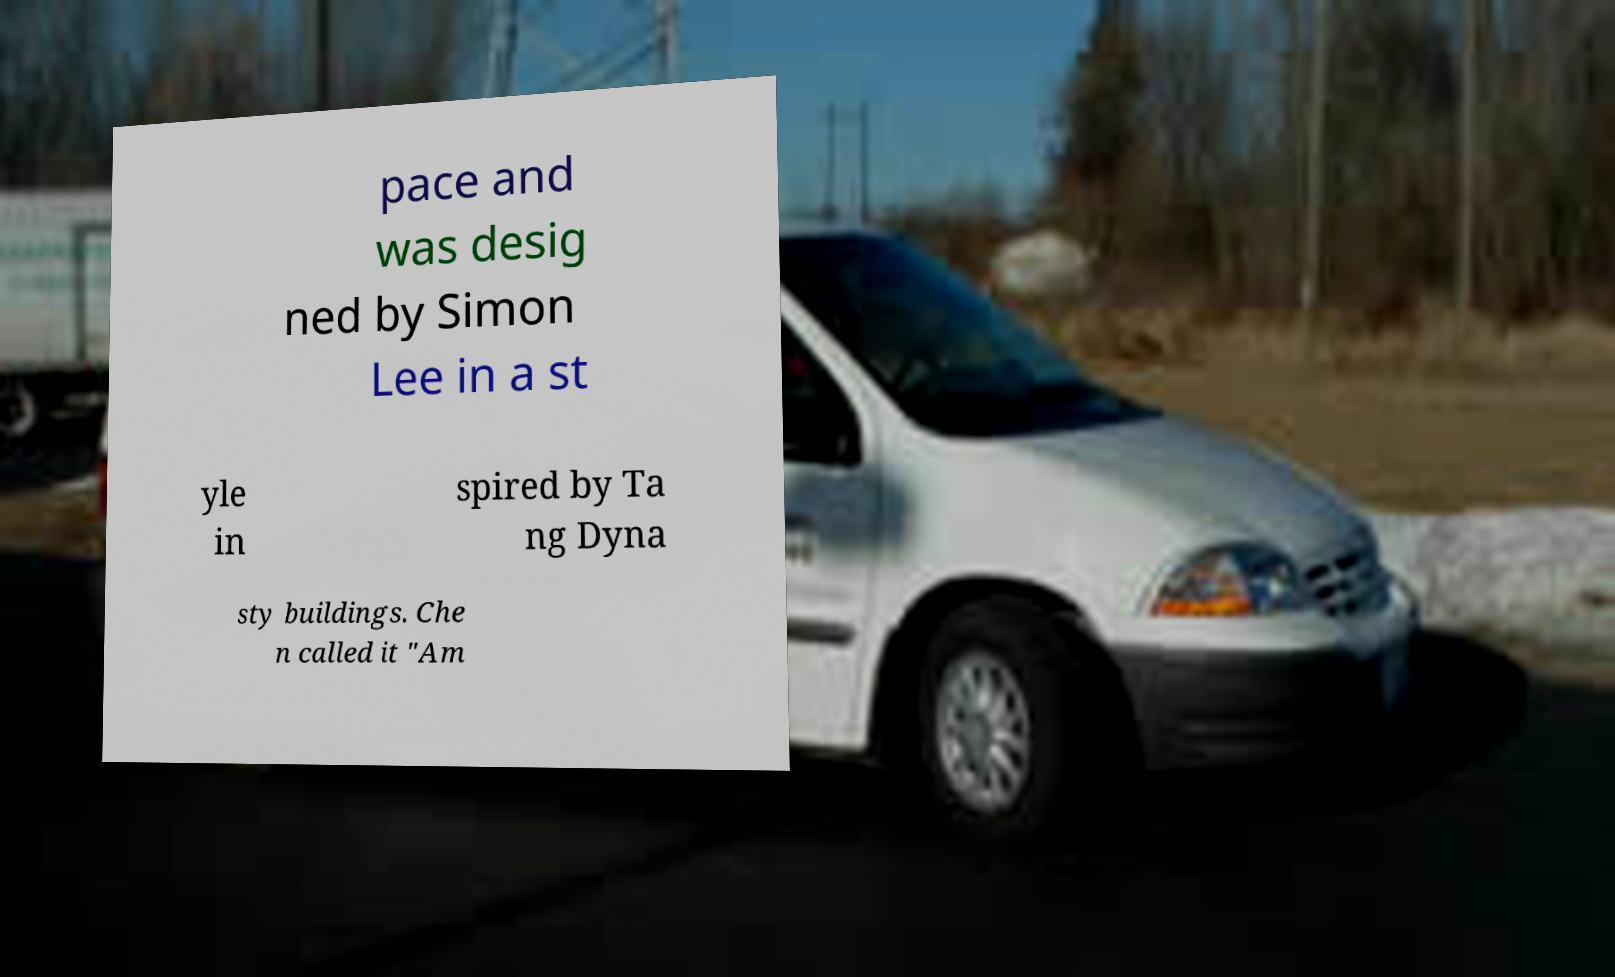Could you assist in decoding the text presented in this image and type it out clearly? pace and was desig ned by Simon Lee in a st yle in spired by Ta ng Dyna sty buildings. Che n called it "Am 